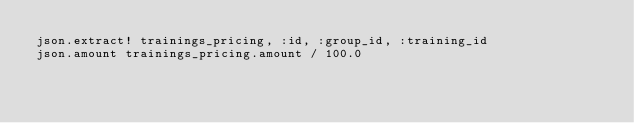<code> <loc_0><loc_0><loc_500><loc_500><_Ruby_>json.extract! trainings_pricing, :id, :group_id, :training_id
json.amount trainings_pricing.amount / 100.0
</code> 